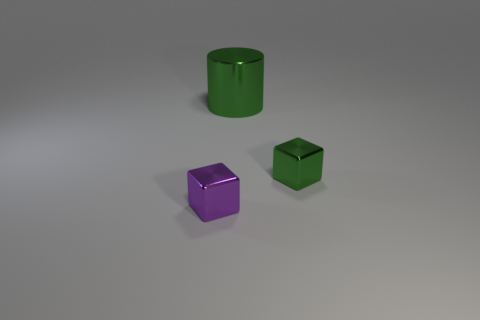What number of purple objects are big shiny cylinders or cubes?
Offer a very short reply. 1. Is there a big metal cylinder left of the green shiny thing that is behind the green shiny object in front of the green metal cylinder?
Keep it short and to the point. No. Is there any other thing that is the same size as the purple thing?
Keep it short and to the point. Yes. What color is the tiny metallic thing left of the tiny block that is right of the cylinder?
Ensure brevity in your answer.  Purple. What number of big objects are blue blocks or green metallic blocks?
Give a very brief answer. 0. The metallic object that is both left of the green metallic cube and in front of the big green metallic cylinder is what color?
Offer a terse response. Purple. Do the small purple cube and the tiny green cube have the same material?
Ensure brevity in your answer.  Yes. What is the shape of the small green metal object?
Make the answer very short. Cube. What number of green metal things are right of the tiny metallic object behind the thing in front of the small green metallic cube?
Your answer should be very brief. 0. The other metallic object that is the same shape as the purple thing is what color?
Your answer should be very brief. Green. 